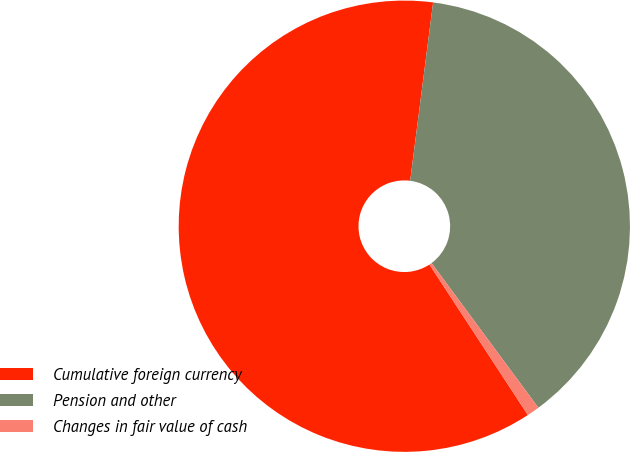Convert chart to OTSL. <chart><loc_0><loc_0><loc_500><loc_500><pie_chart><fcel>Cumulative foreign currency<fcel>Pension and other<fcel>Changes in fair value of cash<nl><fcel>61.26%<fcel>37.84%<fcel>0.9%<nl></chart> 